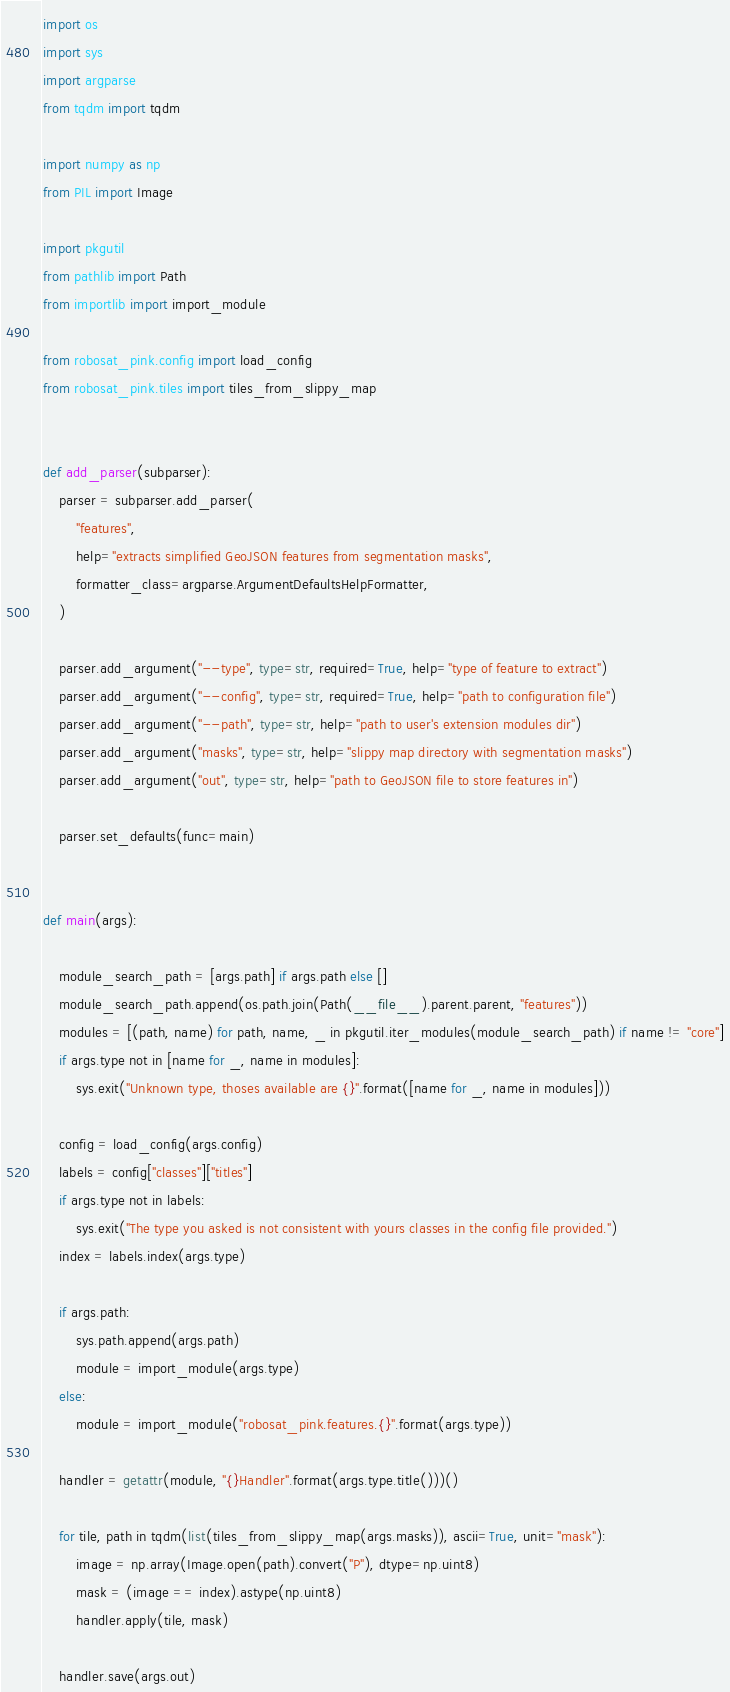Convert code to text. <code><loc_0><loc_0><loc_500><loc_500><_Python_>import os
import sys
import argparse
from tqdm import tqdm

import numpy as np
from PIL import Image

import pkgutil
from pathlib import Path
from importlib import import_module

from robosat_pink.config import load_config
from robosat_pink.tiles import tiles_from_slippy_map


def add_parser(subparser):
    parser = subparser.add_parser(
        "features",
        help="extracts simplified GeoJSON features from segmentation masks",
        formatter_class=argparse.ArgumentDefaultsHelpFormatter,
    )

    parser.add_argument("--type", type=str, required=True, help="type of feature to extract")
    parser.add_argument("--config", type=str, required=True, help="path to configuration file")
    parser.add_argument("--path", type=str, help="path to user's extension modules dir")
    parser.add_argument("masks", type=str, help="slippy map directory with segmentation masks")
    parser.add_argument("out", type=str, help="path to GeoJSON file to store features in")

    parser.set_defaults(func=main)


def main(args):

    module_search_path = [args.path] if args.path else []
    module_search_path.append(os.path.join(Path(__file__).parent.parent, "features"))
    modules = [(path, name) for path, name, _ in pkgutil.iter_modules(module_search_path) if name != "core"]
    if args.type not in [name for _, name in modules]:
        sys.exit("Unknown type, thoses available are {}".format([name for _, name in modules]))

    config = load_config(args.config)
    labels = config["classes"]["titles"]
    if args.type not in labels:
        sys.exit("The type you asked is not consistent with yours classes in the config file provided.")
    index = labels.index(args.type)

    if args.path:
        sys.path.append(args.path)
        module = import_module(args.type)
    else:
        module = import_module("robosat_pink.features.{}".format(args.type))

    handler = getattr(module, "{}Handler".format(args.type.title()))()

    for tile, path in tqdm(list(tiles_from_slippy_map(args.masks)), ascii=True, unit="mask"):
        image = np.array(Image.open(path).convert("P"), dtype=np.uint8)
        mask = (image == index).astype(np.uint8)
        handler.apply(tile, mask)

    handler.save(args.out)
</code> 